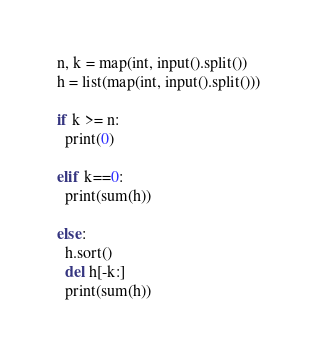<code> <loc_0><loc_0><loc_500><loc_500><_Python_>n, k = map(int, input().split())
h = list(map(int, input().split()))

if k >= n:
  print(0)

elif k==0:
  print(sum(h))

else:
  h.sort()
  del h[-k:]
  print(sum(h))</code> 